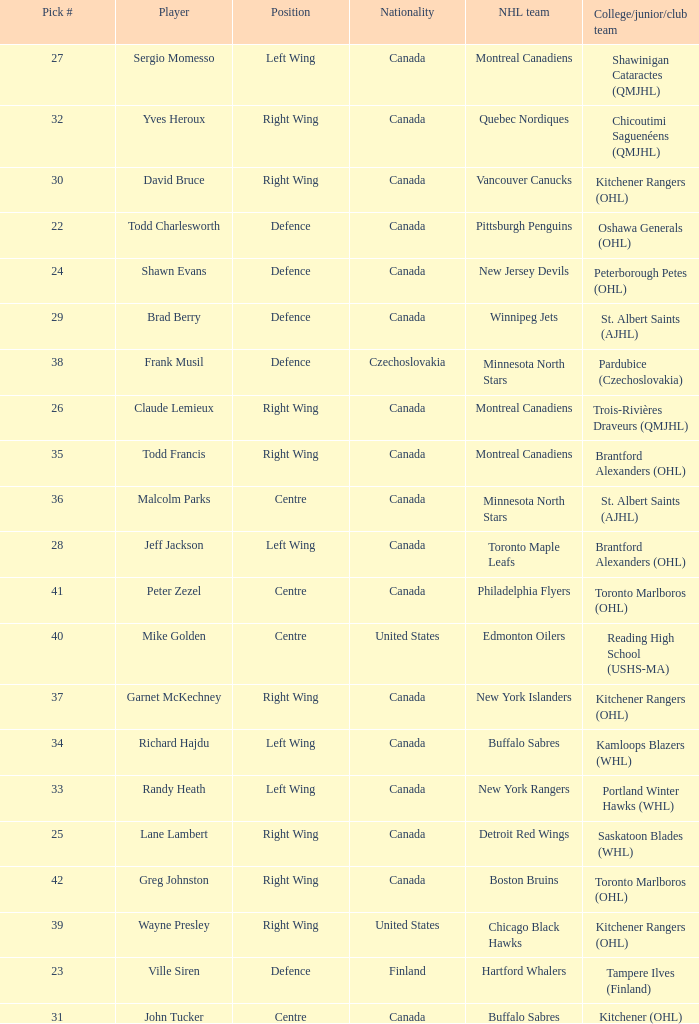What is the nationality when the player is randy heath? Canada. 